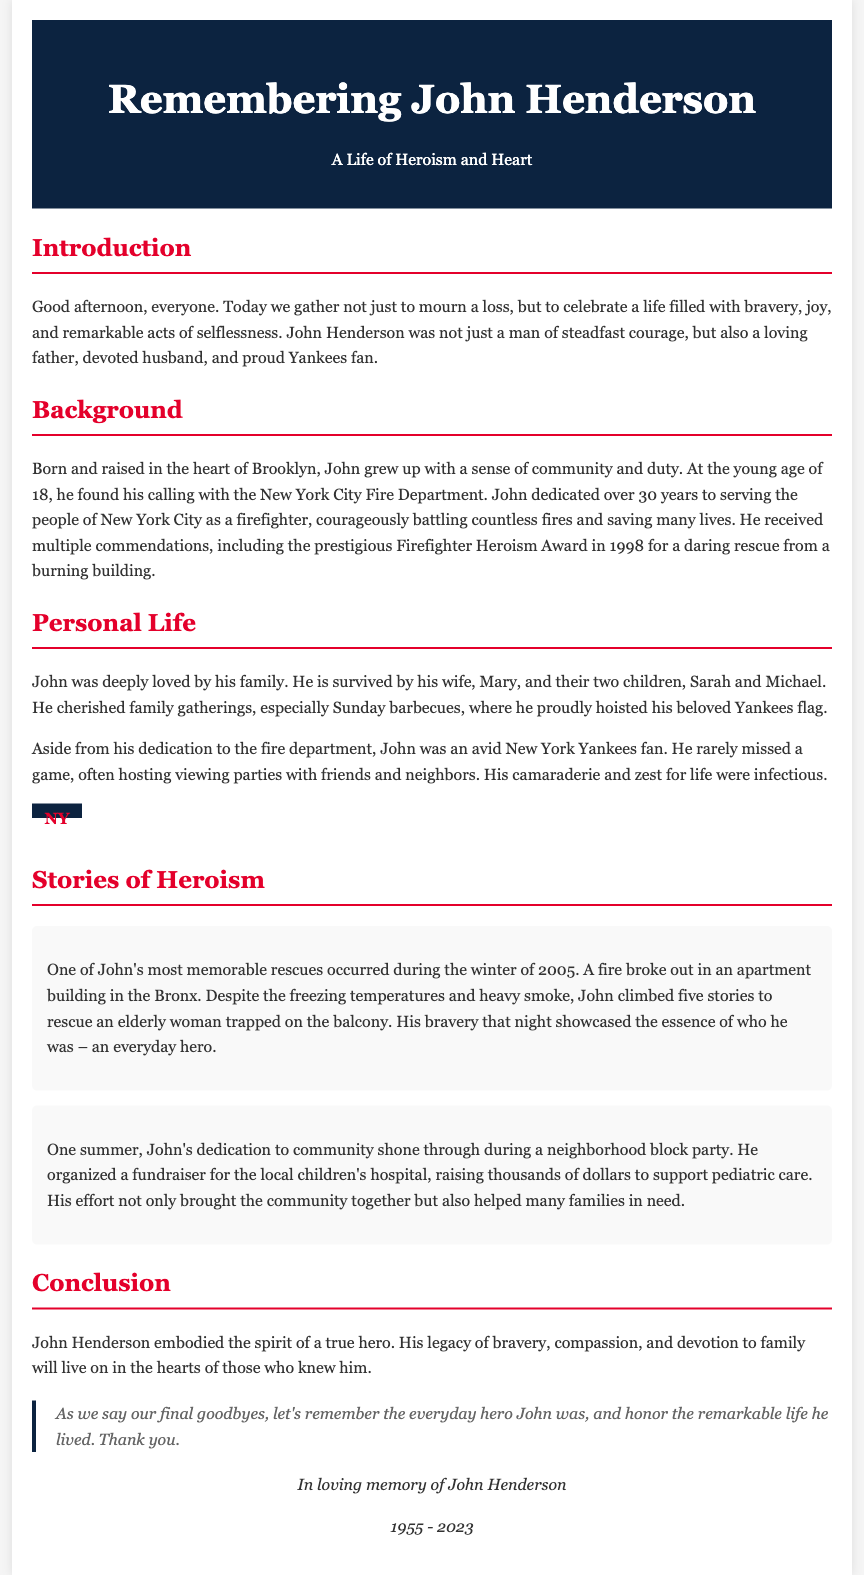What is the title of the eulogy? The title of the eulogy is found in the header section and introduces the subject of remembrance.
Answer: Remembering John Henderson: A Life of Heroism Who is the author of the eulogy about? The eulogy focuses on the life and contributions of a specific individual, mentioned in the introduction.
Answer: John Henderson How many children did John Henderson have? The document provides family information, specifying how many children he has.
Answer: Two What award did John receive in 1998? The eulogy highlights an important accomplishment of John in his firefighting career.
Answer: Firefighter Heroism Award During which event did John organize a fundraiser? The document records significant events that show John's community involvement and character.
Answer: Neighborhood block party What was John Henderson's notable rescue year? The eulogy recounts a significant heroism story with a specific year indicated.
Answer: 2005 What was a key trait of John mentioned in multiple sections? The document emphasizes recurring themes in John's life and character throughout its sections.
Answer: Heroism Which sports team did John passionately support? The eulogy points out John's personal interests related to sports, highlighting his fandom.
Answer: New York Yankees In what year did John Henderson pass away? The footer of the document indicates the ending year of John's life.
Answer: 2023 